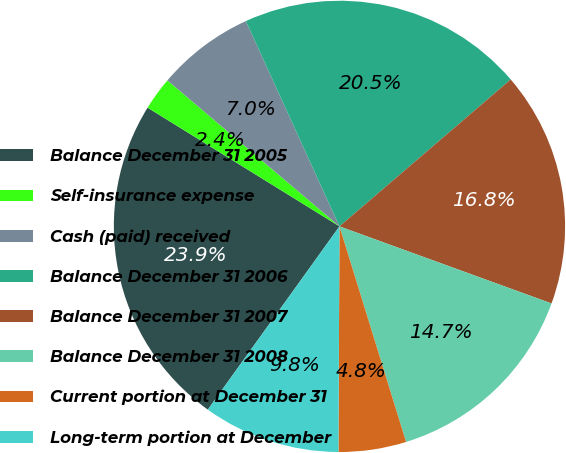Convert chart to OTSL. <chart><loc_0><loc_0><loc_500><loc_500><pie_chart><fcel>Balance December 31 2005<fcel>Self-insurance expense<fcel>Cash (paid) received<fcel>Balance December 31 2006<fcel>Balance December 31 2007<fcel>Balance December 31 2008<fcel>Current portion at December 31<fcel>Long-term portion at December<nl><fcel>23.9%<fcel>2.38%<fcel>6.99%<fcel>20.52%<fcel>16.83%<fcel>14.68%<fcel>4.84%<fcel>9.84%<nl></chart> 